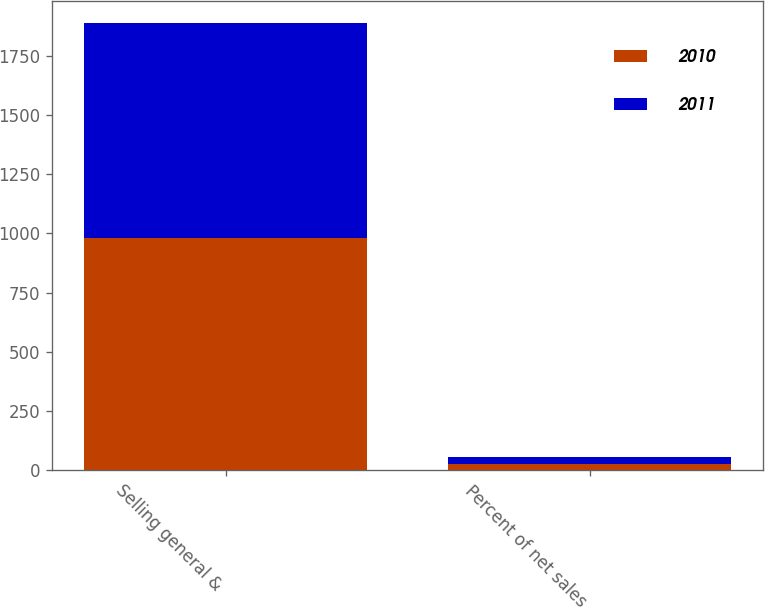<chart> <loc_0><loc_0><loc_500><loc_500><stacked_bar_chart><ecel><fcel>Selling general &<fcel>Percent of net sales<nl><fcel>2010<fcel>982.2<fcel>26.6<nl><fcel>2011<fcel>907.9<fcel>27.2<nl></chart> 